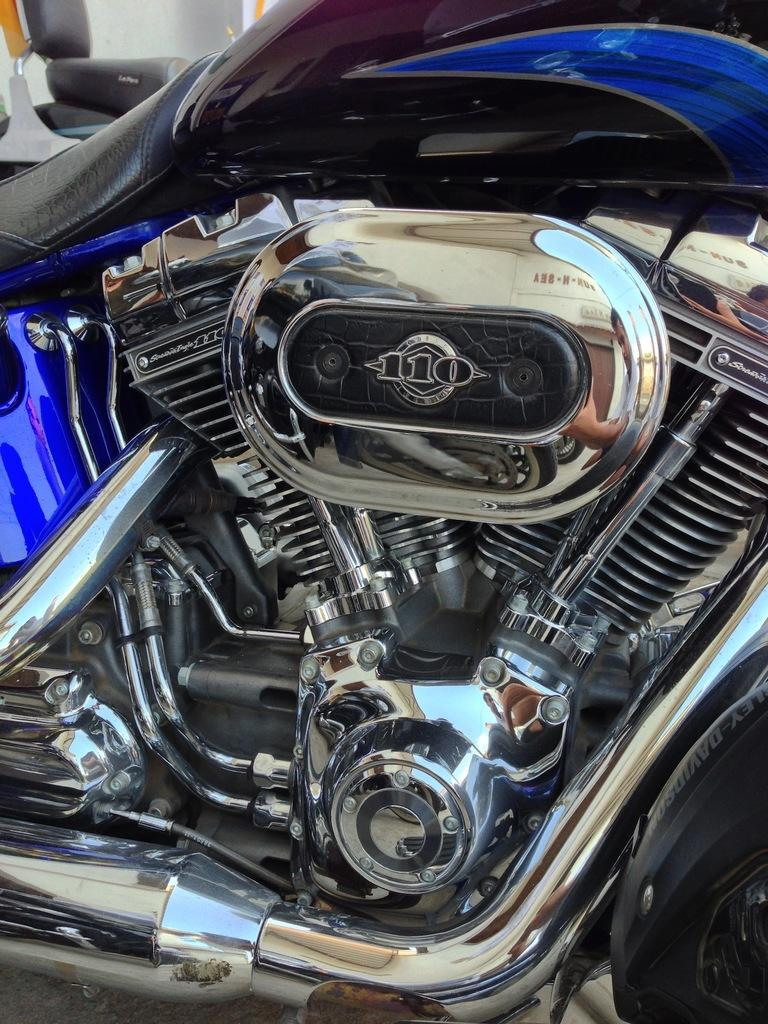What type of vehicle is in the picture? There is a motorbike in the picture. What powers the motorbike? The motorbike has an engine. What part of the motorbike is designed for seating? There is a bike seat visible in the picture. What type of sponge is being used for breakfast on the motorbike? There is no sponge or breakfast present in the image; it only features a motorbike with an engine and a bike seat. 